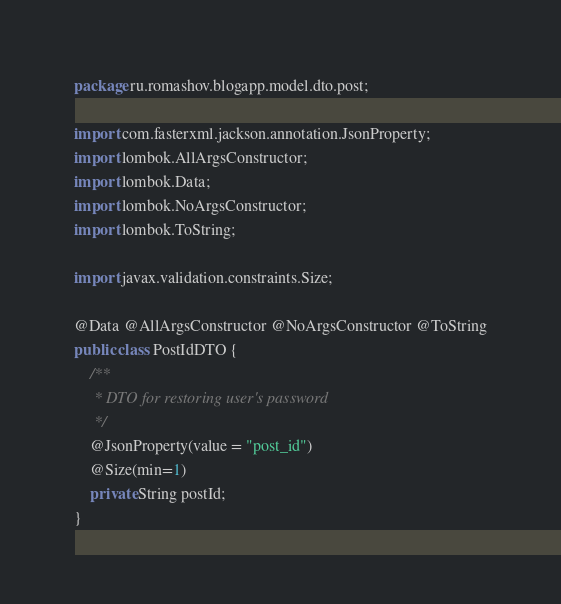<code> <loc_0><loc_0><loc_500><loc_500><_Java_>package ru.romashov.blogapp.model.dto.post;

import com.fasterxml.jackson.annotation.JsonProperty;
import lombok.AllArgsConstructor;
import lombok.Data;
import lombok.NoArgsConstructor;
import lombok.ToString;

import javax.validation.constraints.Size;

@Data @AllArgsConstructor @NoArgsConstructor @ToString
public class PostIdDTO {
    /**
     * DTO for restoring user's password
     */
    @JsonProperty(value = "post_id")
    @Size(min=1)
    private String postId;
}
</code> 